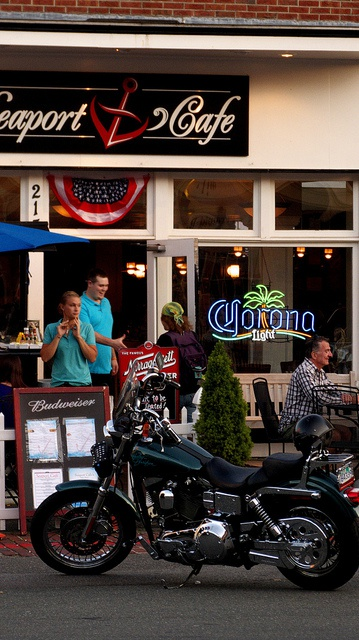Describe the objects in this image and their specific colors. I can see motorcycle in maroon, black, gray, and lightgray tones, people in maroon, teal, and black tones, people in maroon, black, gray, and darkgray tones, people in maroon, lightblue, black, and teal tones, and people in maroon, black, olive, and gray tones in this image. 